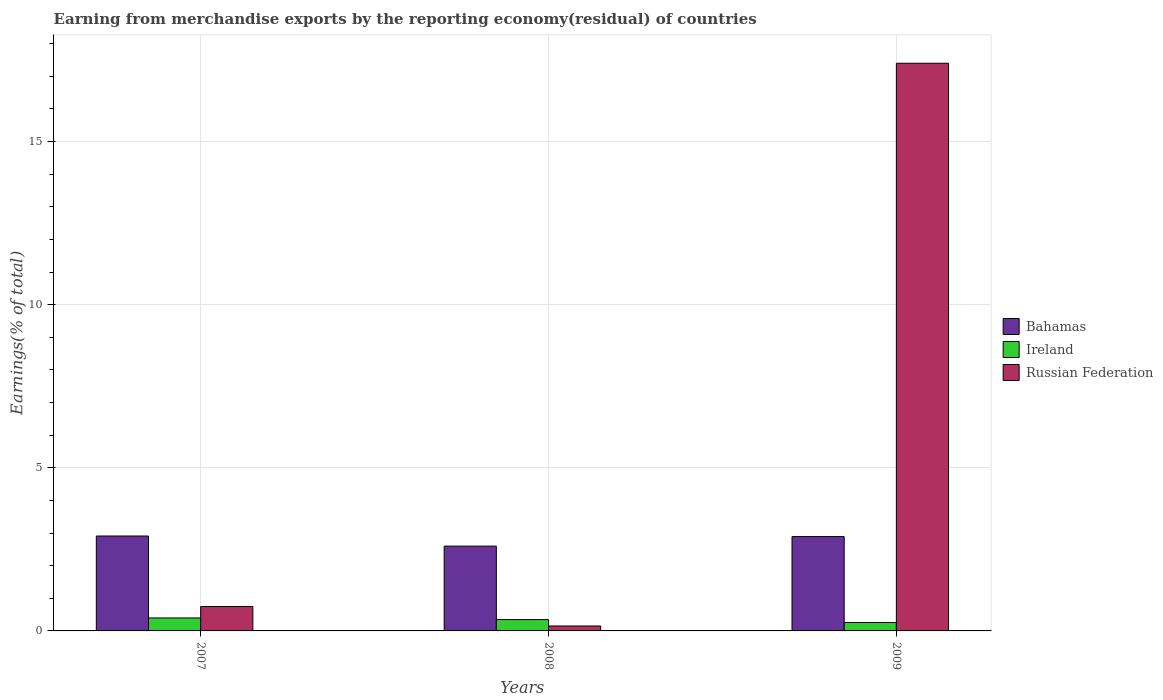Are the number of bars on each tick of the X-axis equal?
Offer a very short reply. Yes. How many bars are there on the 3rd tick from the left?
Make the answer very short. 3. How many bars are there on the 3rd tick from the right?
Ensure brevity in your answer.  3. What is the label of the 2nd group of bars from the left?
Provide a succinct answer. 2008. What is the percentage of amount earned from merchandise exports in Bahamas in 2009?
Your answer should be compact. 2.89. Across all years, what is the maximum percentage of amount earned from merchandise exports in Russian Federation?
Your answer should be very brief. 17.4. Across all years, what is the minimum percentage of amount earned from merchandise exports in Ireland?
Ensure brevity in your answer.  0.26. In which year was the percentage of amount earned from merchandise exports in Russian Federation maximum?
Make the answer very short. 2009. In which year was the percentage of amount earned from merchandise exports in Russian Federation minimum?
Provide a succinct answer. 2008. What is the total percentage of amount earned from merchandise exports in Ireland in the graph?
Provide a succinct answer. 1. What is the difference between the percentage of amount earned from merchandise exports in Bahamas in 2007 and that in 2008?
Ensure brevity in your answer.  0.31. What is the difference between the percentage of amount earned from merchandise exports in Russian Federation in 2008 and the percentage of amount earned from merchandise exports in Bahamas in 2007?
Keep it short and to the point. -2.76. What is the average percentage of amount earned from merchandise exports in Russian Federation per year?
Ensure brevity in your answer.  6.1. In the year 2009, what is the difference between the percentage of amount earned from merchandise exports in Russian Federation and percentage of amount earned from merchandise exports in Bahamas?
Keep it short and to the point. 14.51. In how many years, is the percentage of amount earned from merchandise exports in Ireland greater than 16 %?
Keep it short and to the point. 0. What is the ratio of the percentage of amount earned from merchandise exports in Bahamas in 2008 to that in 2009?
Make the answer very short. 0.9. Is the percentage of amount earned from merchandise exports in Bahamas in 2007 less than that in 2008?
Your response must be concise. No. Is the difference between the percentage of amount earned from merchandise exports in Russian Federation in 2008 and 2009 greater than the difference between the percentage of amount earned from merchandise exports in Bahamas in 2008 and 2009?
Offer a very short reply. No. What is the difference between the highest and the second highest percentage of amount earned from merchandise exports in Russian Federation?
Provide a short and direct response. 16.65. What is the difference between the highest and the lowest percentage of amount earned from merchandise exports in Ireland?
Offer a terse response. 0.14. In how many years, is the percentage of amount earned from merchandise exports in Ireland greater than the average percentage of amount earned from merchandise exports in Ireland taken over all years?
Provide a short and direct response. 2. Is the sum of the percentage of amount earned from merchandise exports in Bahamas in 2007 and 2008 greater than the maximum percentage of amount earned from merchandise exports in Russian Federation across all years?
Your response must be concise. No. What does the 2nd bar from the left in 2008 represents?
Make the answer very short. Ireland. What does the 2nd bar from the right in 2007 represents?
Give a very brief answer. Ireland. How many years are there in the graph?
Ensure brevity in your answer.  3. What is the difference between two consecutive major ticks on the Y-axis?
Your response must be concise. 5. Does the graph contain any zero values?
Your answer should be very brief. No. Does the graph contain grids?
Provide a short and direct response. Yes. How many legend labels are there?
Offer a terse response. 3. What is the title of the graph?
Ensure brevity in your answer.  Earning from merchandise exports by the reporting economy(residual) of countries. What is the label or title of the X-axis?
Your answer should be compact. Years. What is the label or title of the Y-axis?
Give a very brief answer. Earnings(% of total). What is the Earnings(% of total) of Bahamas in 2007?
Make the answer very short. 2.91. What is the Earnings(% of total) in Ireland in 2007?
Provide a succinct answer. 0.4. What is the Earnings(% of total) in Russian Federation in 2007?
Offer a terse response. 0.75. What is the Earnings(% of total) in Bahamas in 2008?
Make the answer very short. 2.6. What is the Earnings(% of total) of Ireland in 2008?
Your answer should be very brief. 0.35. What is the Earnings(% of total) of Russian Federation in 2008?
Provide a short and direct response. 0.15. What is the Earnings(% of total) of Bahamas in 2009?
Ensure brevity in your answer.  2.89. What is the Earnings(% of total) of Ireland in 2009?
Offer a terse response. 0.26. What is the Earnings(% of total) in Russian Federation in 2009?
Offer a very short reply. 17.4. Across all years, what is the maximum Earnings(% of total) of Bahamas?
Keep it short and to the point. 2.91. Across all years, what is the maximum Earnings(% of total) in Ireland?
Ensure brevity in your answer.  0.4. Across all years, what is the maximum Earnings(% of total) in Russian Federation?
Offer a very short reply. 17.4. Across all years, what is the minimum Earnings(% of total) in Bahamas?
Offer a terse response. 2.6. Across all years, what is the minimum Earnings(% of total) in Ireland?
Your answer should be very brief. 0.26. Across all years, what is the minimum Earnings(% of total) of Russian Federation?
Offer a terse response. 0.15. What is the total Earnings(% of total) in Bahamas in the graph?
Provide a short and direct response. 8.4. What is the total Earnings(% of total) of Ireland in the graph?
Make the answer very short. 1. What is the total Earnings(% of total) in Russian Federation in the graph?
Make the answer very short. 18.3. What is the difference between the Earnings(% of total) in Bahamas in 2007 and that in 2008?
Keep it short and to the point. 0.31. What is the difference between the Earnings(% of total) of Ireland in 2007 and that in 2008?
Keep it short and to the point. 0.05. What is the difference between the Earnings(% of total) in Russian Federation in 2007 and that in 2008?
Offer a terse response. 0.6. What is the difference between the Earnings(% of total) in Bahamas in 2007 and that in 2009?
Offer a terse response. 0.02. What is the difference between the Earnings(% of total) of Ireland in 2007 and that in 2009?
Your answer should be very brief. 0.14. What is the difference between the Earnings(% of total) of Russian Federation in 2007 and that in 2009?
Give a very brief answer. -16.65. What is the difference between the Earnings(% of total) of Bahamas in 2008 and that in 2009?
Make the answer very short. -0.29. What is the difference between the Earnings(% of total) of Ireland in 2008 and that in 2009?
Ensure brevity in your answer.  0.09. What is the difference between the Earnings(% of total) in Russian Federation in 2008 and that in 2009?
Provide a succinct answer. -17.25. What is the difference between the Earnings(% of total) in Bahamas in 2007 and the Earnings(% of total) in Ireland in 2008?
Offer a very short reply. 2.56. What is the difference between the Earnings(% of total) in Bahamas in 2007 and the Earnings(% of total) in Russian Federation in 2008?
Your answer should be compact. 2.76. What is the difference between the Earnings(% of total) in Ireland in 2007 and the Earnings(% of total) in Russian Federation in 2008?
Offer a terse response. 0.25. What is the difference between the Earnings(% of total) of Bahamas in 2007 and the Earnings(% of total) of Ireland in 2009?
Provide a succinct answer. 2.65. What is the difference between the Earnings(% of total) of Bahamas in 2007 and the Earnings(% of total) of Russian Federation in 2009?
Keep it short and to the point. -14.49. What is the difference between the Earnings(% of total) in Ireland in 2007 and the Earnings(% of total) in Russian Federation in 2009?
Make the answer very short. -17. What is the difference between the Earnings(% of total) in Bahamas in 2008 and the Earnings(% of total) in Ireland in 2009?
Make the answer very short. 2.34. What is the difference between the Earnings(% of total) in Bahamas in 2008 and the Earnings(% of total) in Russian Federation in 2009?
Your response must be concise. -14.8. What is the difference between the Earnings(% of total) of Ireland in 2008 and the Earnings(% of total) of Russian Federation in 2009?
Keep it short and to the point. -17.05. What is the average Earnings(% of total) of Bahamas per year?
Ensure brevity in your answer.  2.8. What is the average Earnings(% of total) of Ireland per year?
Your answer should be very brief. 0.33. What is the average Earnings(% of total) of Russian Federation per year?
Keep it short and to the point. 6.1. In the year 2007, what is the difference between the Earnings(% of total) of Bahamas and Earnings(% of total) of Ireland?
Your answer should be compact. 2.51. In the year 2007, what is the difference between the Earnings(% of total) in Bahamas and Earnings(% of total) in Russian Federation?
Your answer should be compact. 2.16. In the year 2007, what is the difference between the Earnings(% of total) of Ireland and Earnings(% of total) of Russian Federation?
Offer a very short reply. -0.35. In the year 2008, what is the difference between the Earnings(% of total) in Bahamas and Earnings(% of total) in Ireland?
Provide a succinct answer. 2.25. In the year 2008, what is the difference between the Earnings(% of total) in Bahamas and Earnings(% of total) in Russian Federation?
Offer a terse response. 2.45. In the year 2008, what is the difference between the Earnings(% of total) in Ireland and Earnings(% of total) in Russian Federation?
Ensure brevity in your answer.  0.2. In the year 2009, what is the difference between the Earnings(% of total) of Bahamas and Earnings(% of total) of Ireland?
Provide a short and direct response. 2.63. In the year 2009, what is the difference between the Earnings(% of total) of Bahamas and Earnings(% of total) of Russian Federation?
Make the answer very short. -14.51. In the year 2009, what is the difference between the Earnings(% of total) in Ireland and Earnings(% of total) in Russian Federation?
Make the answer very short. -17.14. What is the ratio of the Earnings(% of total) of Bahamas in 2007 to that in 2008?
Your response must be concise. 1.12. What is the ratio of the Earnings(% of total) of Ireland in 2007 to that in 2008?
Offer a very short reply. 1.14. What is the ratio of the Earnings(% of total) of Russian Federation in 2007 to that in 2008?
Give a very brief answer. 4.94. What is the ratio of the Earnings(% of total) of Bahamas in 2007 to that in 2009?
Your answer should be compact. 1.01. What is the ratio of the Earnings(% of total) of Ireland in 2007 to that in 2009?
Offer a terse response. 1.54. What is the ratio of the Earnings(% of total) of Russian Federation in 2007 to that in 2009?
Your answer should be compact. 0.04. What is the ratio of the Earnings(% of total) of Bahamas in 2008 to that in 2009?
Your answer should be very brief. 0.9. What is the ratio of the Earnings(% of total) in Ireland in 2008 to that in 2009?
Your response must be concise. 1.35. What is the ratio of the Earnings(% of total) in Russian Federation in 2008 to that in 2009?
Your response must be concise. 0.01. What is the difference between the highest and the second highest Earnings(% of total) in Bahamas?
Make the answer very short. 0.02. What is the difference between the highest and the second highest Earnings(% of total) in Ireland?
Ensure brevity in your answer.  0.05. What is the difference between the highest and the second highest Earnings(% of total) of Russian Federation?
Give a very brief answer. 16.65. What is the difference between the highest and the lowest Earnings(% of total) of Bahamas?
Provide a short and direct response. 0.31. What is the difference between the highest and the lowest Earnings(% of total) in Ireland?
Keep it short and to the point. 0.14. What is the difference between the highest and the lowest Earnings(% of total) in Russian Federation?
Provide a succinct answer. 17.25. 